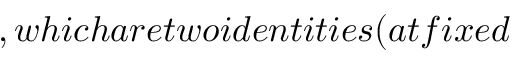Convert formula to latex. <formula><loc_0><loc_0><loc_500><loc_500>, w h i c h a r e t w o i d e n t i t i e s ( a t f i x e d</formula> 